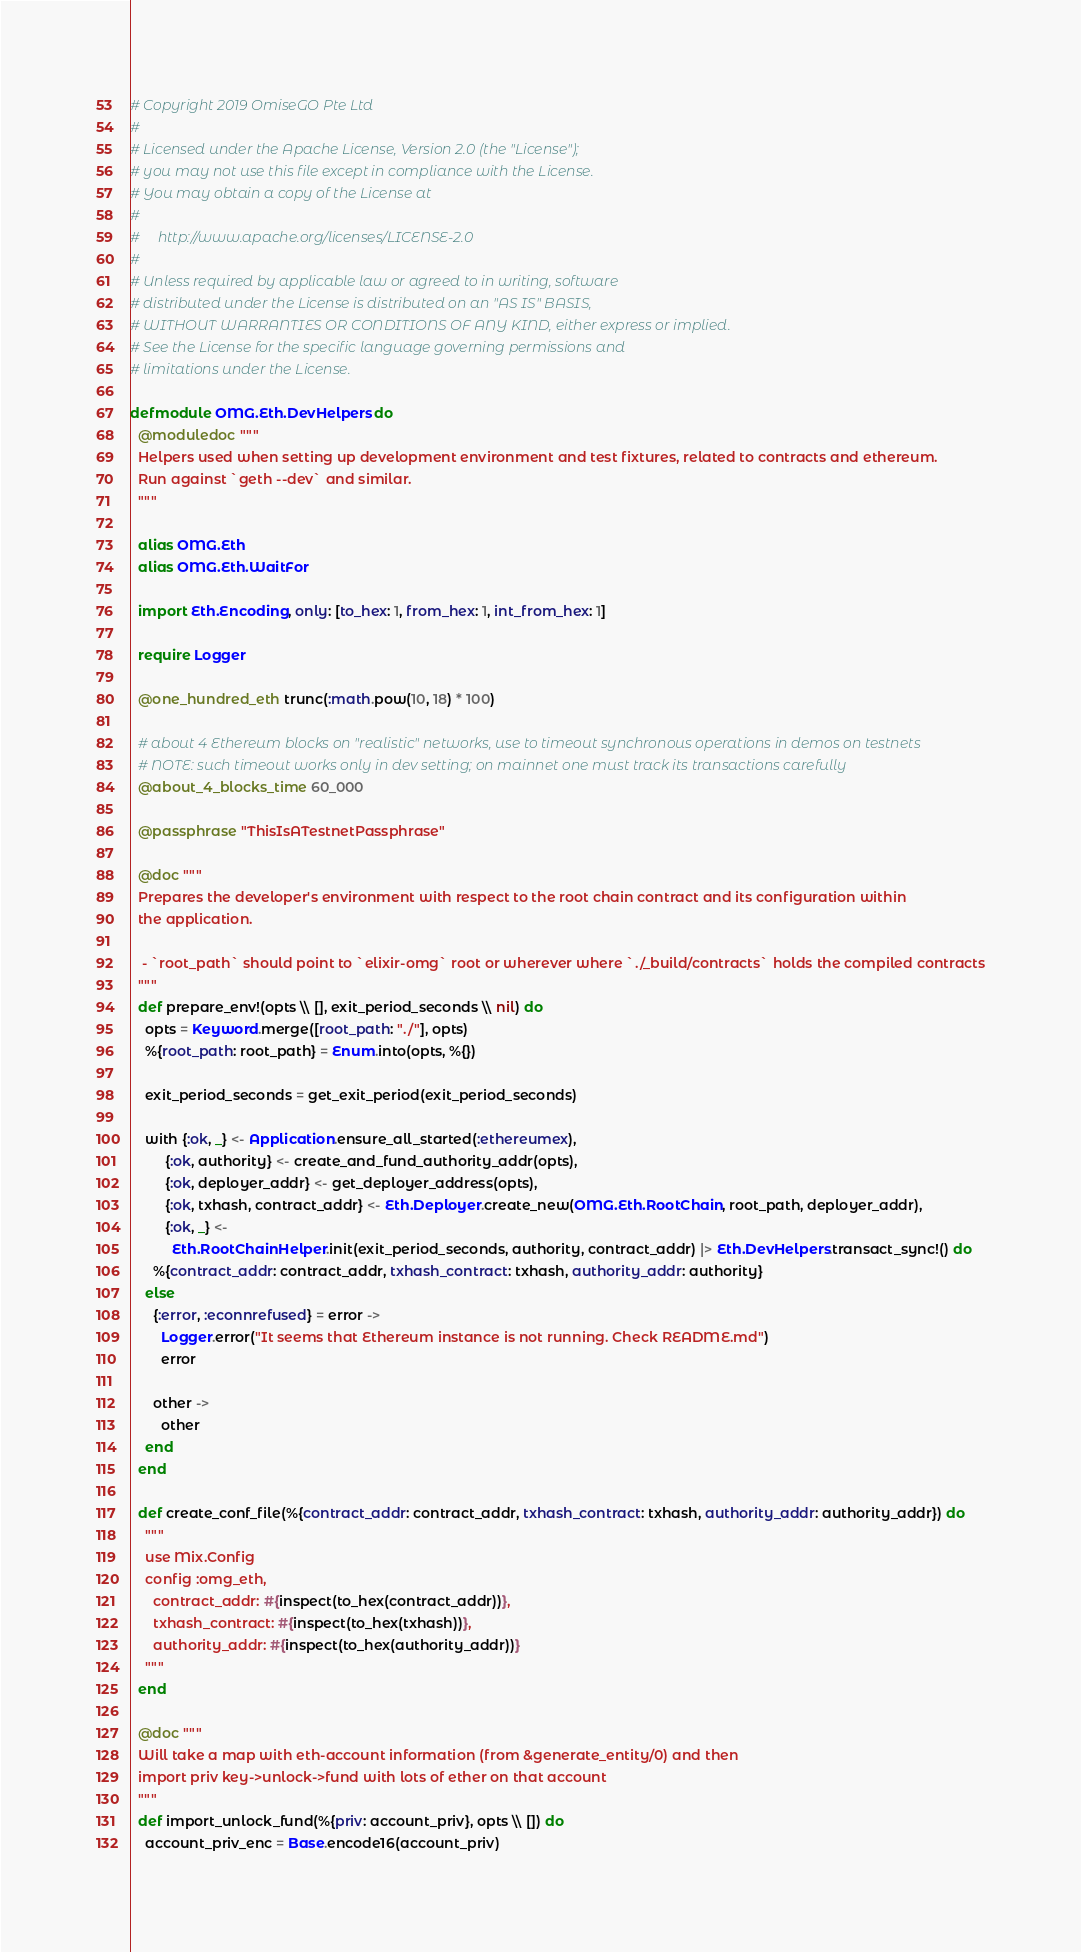<code> <loc_0><loc_0><loc_500><loc_500><_Elixir_># Copyright 2019 OmiseGO Pte Ltd
#
# Licensed under the Apache License, Version 2.0 (the "License");
# you may not use this file except in compliance with the License.
# You may obtain a copy of the License at
#
#     http://www.apache.org/licenses/LICENSE-2.0
#
# Unless required by applicable law or agreed to in writing, software
# distributed under the License is distributed on an "AS IS" BASIS,
# WITHOUT WARRANTIES OR CONDITIONS OF ANY KIND, either express or implied.
# See the License for the specific language governing permissions and
# limitations under the License.

defmodule OMG.Eth.DevHelpers do
  @moduledoc """
  Helpers used when setting up development environment and test fixtures, related to contracts and ethereum.
  Run against `geth --dev` and similar.
  """

  alias OMG.Eth
  alias OMG.Eth.WaitFor

  import Eth.Encoding, only: [to_hex: 1, from_hex: 1, int_from_hex: 1]

  require Logger

  @one_hundred_eth trunc(:math.pow(10, 18) * 100)

  # about 4 Ethereum blocks on "realistic" networks, use to timeout synchronous operations in demos on testnets
  # NOTE: such timeout works only in dev setting; on mainnet one must track its transactions carefully
  @about_4_blocks_time 60_000

  @passphrase "ThisIsATestnetPassphrase"

  @doc """
  Prepares the developer's environment with respect to the root chain contract and its configuration within
  the application.

   - `root_path` should point to `elixir-omg` root or wherever where `./_build/contracts` holds the compiled contracts
  """
  def prepare_env!(opts \\ [], exit_period_seconds \\ nil) do
    opts = Keyword.merge([root_path: "./"], opts)
    %{root_path: root_path} = Enum.into(opts, %{})

    exit_period_seconds = get_exit_period(exit_period_seconds)

    with {:ok, _} <- Application.ensure_all_started(:ethereumex),
         {:ok, authority} <- create_and_fund_authority_addr(opts),
         {:ok, deployer_addr} <- get_deployer_address(opts),
         {:ok, txhash, contract_addr} <- Eth.Deployer.create_new(OMG.Eth.RootChain, root_path, deployer_addr),
         {:ok, _} <-
           Eth.RootChainHelper.init(exit_period_seconds, authority, contract_addr) |> Eth.DevHelpers.transact_sync!() do
      %{contract_addr: contract_addr, txhash_contract: txhash, authority_addr: authority}
    else
      {:error, :econnrefused} = error ->
        Logger.error("It seems that Ethereum instance is not running. Check README.md")
        error

      other ->
        other
    end
  end

  def create_conf_file(%{contract_addr: contract_addr, txhash_contract: txhash, authority_addr: authority_addr}) do
    """
    use Mix.Config
    config :omg_eth,
      contract_addr: #{inspect(to_hex(contract_addr))},
      txhash_contract: #{inspect(to_hex(txhash))},
      authority_addr: #{inspect(to_hex(authority_addr))}
    """
  end

  @doc """
  Will take a map with eth-account information (from &generate_entity/0) and then
  import priv key->unlock->fund with lots of ether on that account
  """
  def import_unlock_fund(%{priv: account_priv}, opts \\ []) do
    account_priv_enc = Base.encode16(account_priv)
</code> 